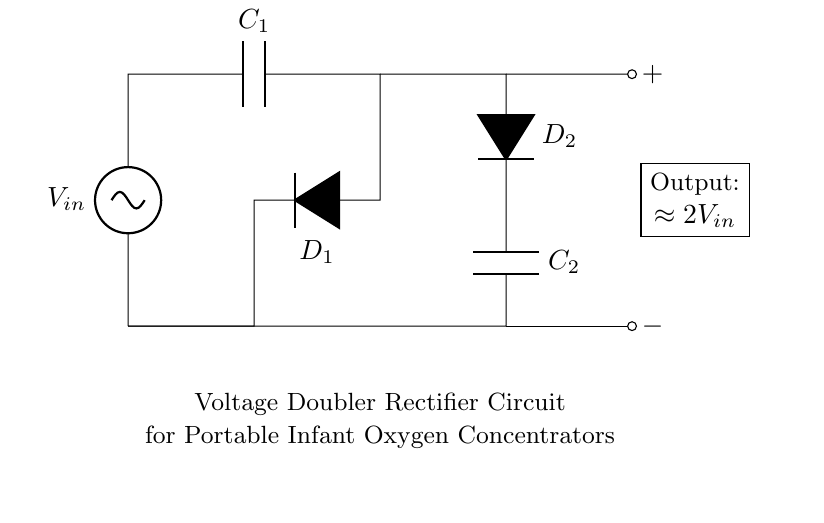What is the function of the circuit? The circuit functions as a voltage doubler, which means it is designed to output approximately double the input voltage. This is seen in the designation in the circuit diagram.
Answer: voltage doubler What type of components are D1 and D2? D1 and D2 are diodes, as indicated by the "D*" notation in the circuit. Diodes allow current to flow in one direction and are essential for rectification in this circuit.
Answer: diodes What is the role of capacitors C1 and C2? Capacitors C1 and C2 store electrical energy and help smooth out the output voltage by charging and discharging. In a voltage doubler, they are crucial for doubling the voltage effectively.
Answer: store energy How many capacitors are used in this circuit? The circuit uses two capacitors, C1 and C2. This is verified by counting the capacitors represented in the diagram.
Answer: two What is the approximate output voltage of this circuit? The output voltage of this voltage doubler circuit is approximately two times the input voltage, indicated in the output label of the diagram.
Answer: approximately 2V in What happens to the input voltage if this circuit is functioning? As the circuit functions, the input voltage is effectively doubled at the output. This is achieved through the sequential action of the diodes and capacitors during each cycle of operation.
Answer: doubled What is the significance of the 'short' connections in the circuit? The 'short' connections serve as conductive paths between the various components of the circuit, allowing current flow. They are crucial for establishing the proper connections without any resistance.
Answer: conductive paths 